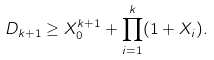Convert formula to latex. <formula><loc_0><loc_0><loc_500><loc_500>D _ { k + 1 } \geq X _ { 0 } ^ { k + 1 } + \prod _ { i = 1 } ^ { k } ( 1 + X _ { i } ) .</formula> 